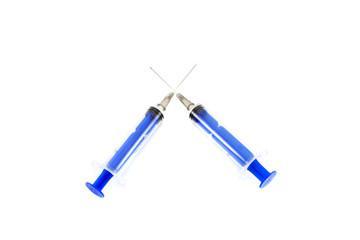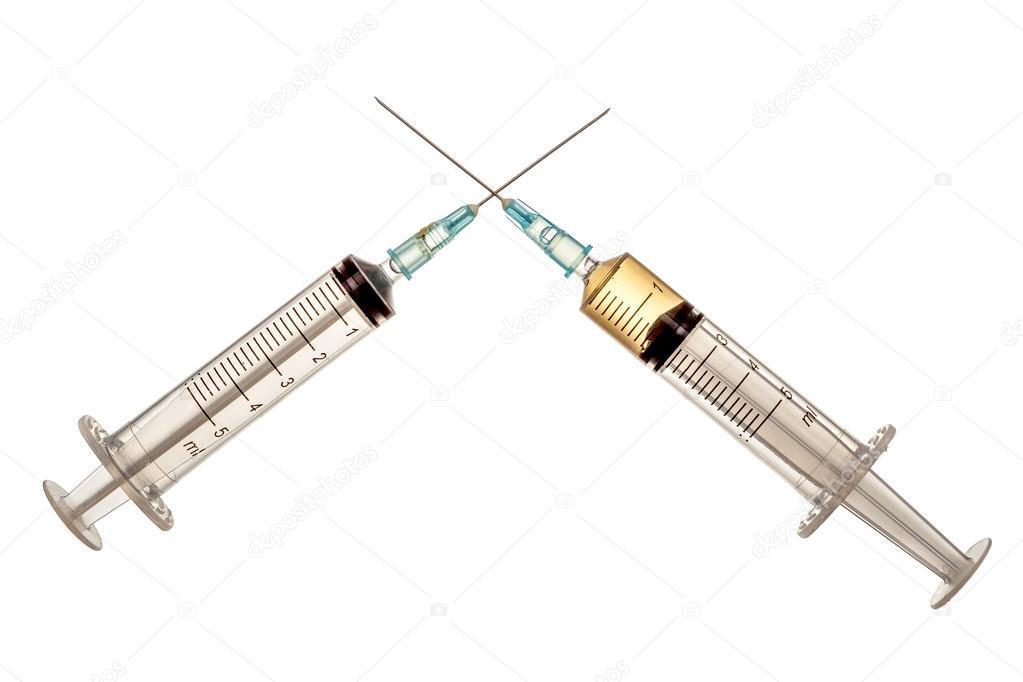The first image is the image on the left, the second image is the image on the right. Evaluate the accuracy of this statement regarding the images: "The left image contains exactly three syringes.". Is it true? Answer yes or no. No. The first image is the image on the left, the second image is the image on the right. Evaluate the accuracy of this statement regarding the images: "Two or more syringes are shown with their metal needles crossed over each other in at least one of the images.". Is it true? Answer yes or no. Yes. 